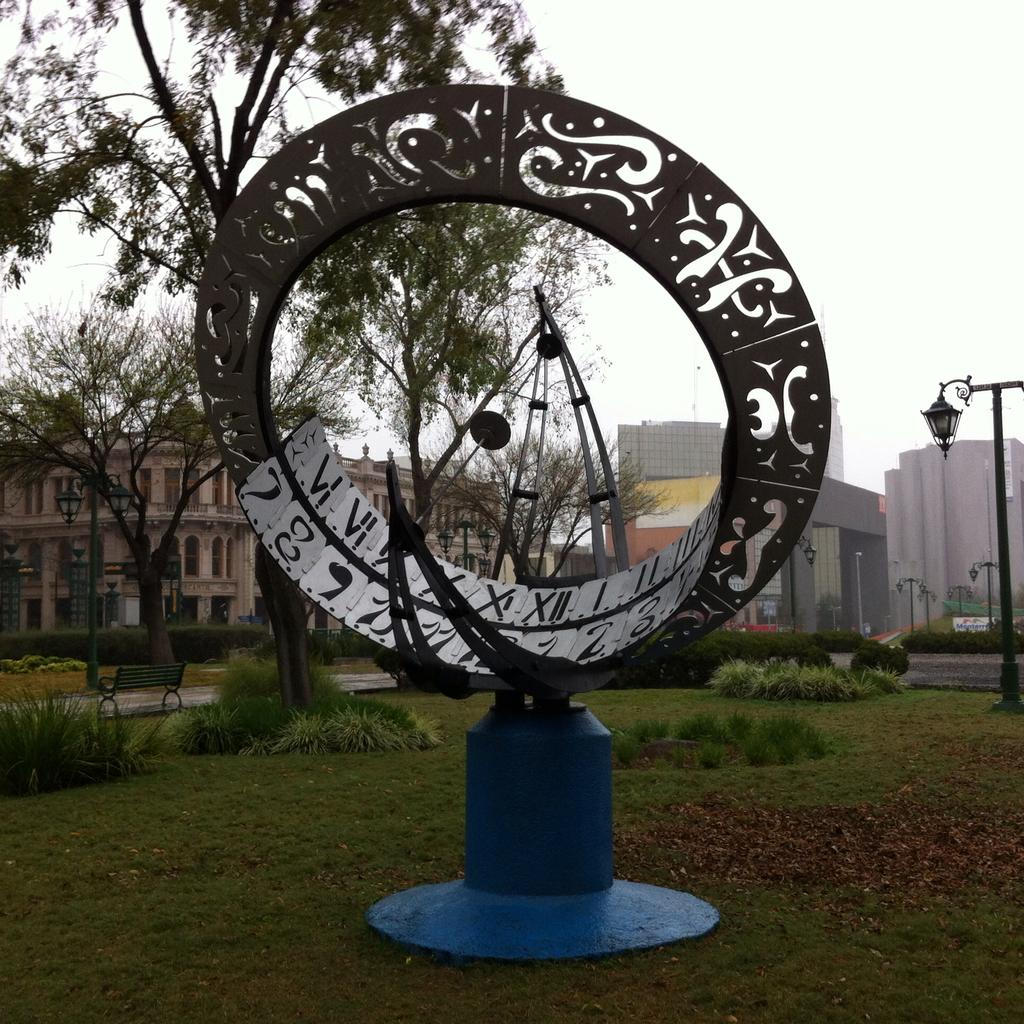What is the main subject in the foreground of the image? There is a statue in the foreground of the image. Where is the statue located? The statue is on the grass. What can be seen in the background of the image? There are trees, plants, grass, a pole, buildings, and the sky visible in the background of the image. Can you see any wrist movements from the laborers in the image? There are no laborers or wrist movements present in the image; it features a statue on the grass with various elements in the background. Are there any dinosaurs visible in the image? There are no dinosaurs present in the image; it features a statue on the grass with various elements in the background. 